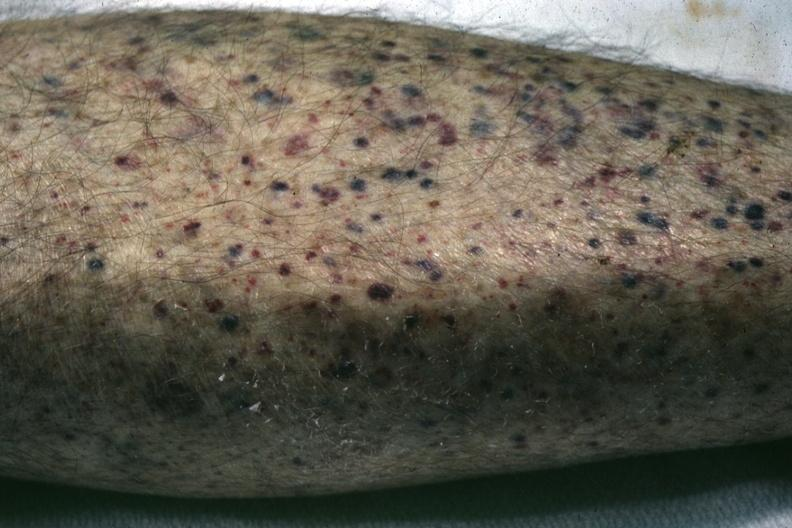what does this image show?
Answer the question using a single word or phrase. White skin close-up view quite good 